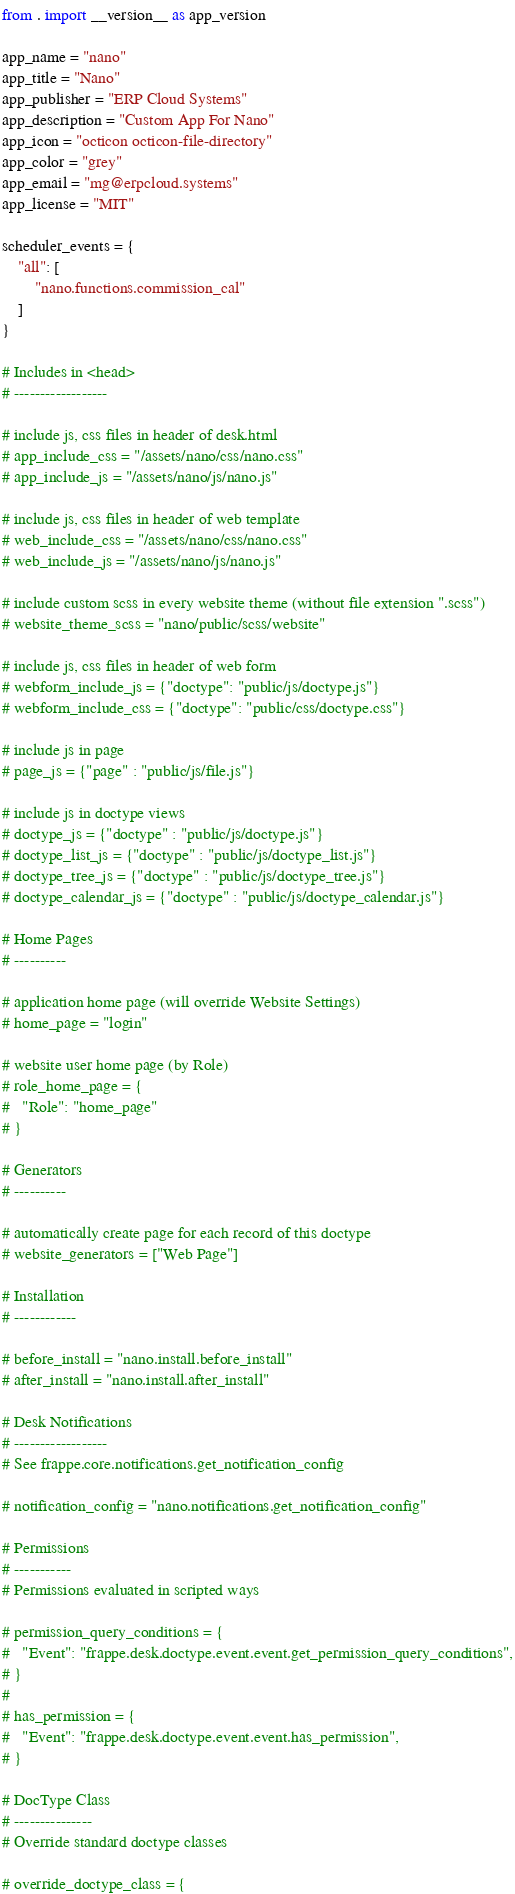Convert code to text. <code><loc_0><loc_0><loc_500><loc_500><_Python_>from . import __version__ as app_version

app_name = "nano"
app_title = "Nano"
app_publisher = "ERP Cloud Systems"
app_description = "Custom App For Nano"
app_icon = "octicon octicon-file-directory"
app_color = "grey"
app_email = "mg@erpcloud.systems"
app_license = "MIT"

scheduler_events = {
	"all": [
		"nano.functions.commission_cal"
	]
}

# Includes in <head>
# ------------------

# include js, css files in header of desk.html
# app_include_css = "/assets/nano/css/nano.css"
# app_include_js = "/assets/nano/js/nano.js"

# include js, css files in header of web template
# web_include_css = "/assets/nano/css/nano.css"
# web_include_js = "/assets/nano/js/nano.js"

# include custom scss in every website theme (without file extension ".scss")
# website_theme_scss = "nano/public/scss/website"

# include js, css files in header of web form
# webform_include_js = {"doctype": "public/js/doctype.js"}
# webform_include_css = {"doctype": "public/css/doctype.css"}

# include js in page
# page_js = {"page" : "public/js/file.js"}

# include js in doctype views
# doctype_js = {"doctype" : "public/js/doctype.js"}
# doctype_list_js = {"doctype" : "public/js/doctype_list.js"}
# doctype_tree_js = {"doctype" : "public/js/doctype_tree.js"}
# doctype_calendar_js = {"doctype" : "public/js/doctype_calendar.js"}

# Home Pages
# ----------

# application home page (will override Website Settings)
# home_page = "login"

# website user home page (by Role)
# role_home_page = {
#	"Role": "home_page"
# }

# Generators
# ----------

# automatically create page for each record of this doctype
# website_generators = ["Web Page"]

# Installation
# ------------

# before_install = "nano.install.before_install"
# after_install = "nano.install.after_install"

# Desk Notifications
# ------------------
# See frappe.core.notifications.get_notification_config

# notification_config = "nano.notifications.get_notification_config"

# Permissions
# -----------
# Permissions evaluated in scripted ways

# permission_query_conditions = {
# 	"Event": "frappe.desk.doctype.event.event.get_permission_query_conditions",
# }
#
# has_permission = {
# 	"Event": "frappe.desk.doctype.event.event.has_permission",
# }

# DocType Class
# ---------------
# Override standard doctype classes

# override_doctype_class = {</code> 